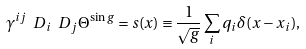Convert formula to latex. <formula><loc_0><loc_0><loc_500><loc_500>\gamma ^ { i j } \ D _ { i } \ D _ { j } \Theta ^ { \sin g } = s ( x ) \equiv \frac { 1 } { \sqrt { g } } \sum _ { i } q _ { i } \delta ( x - x _ { i } ) ,</formula> 